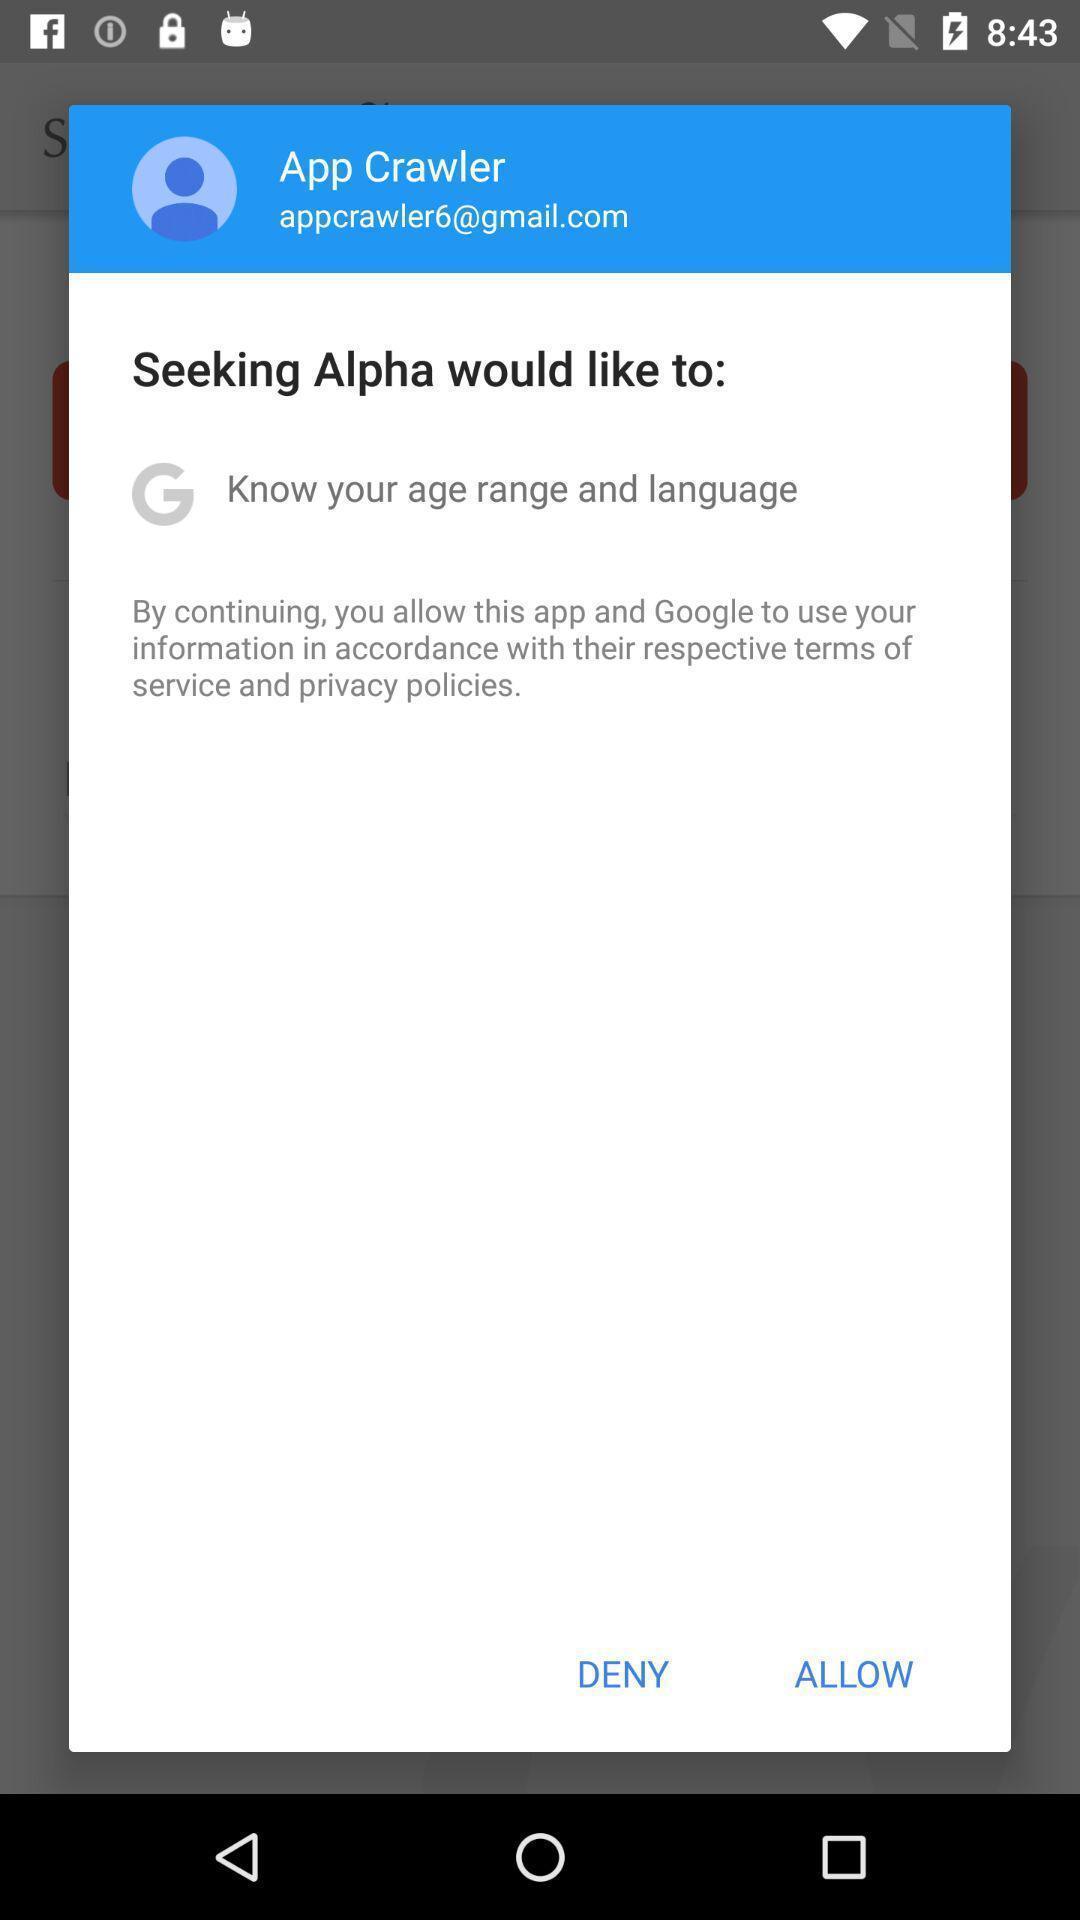What details can you identify in this image? Popup displaying to allow an app to use social account. 